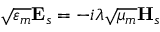<formula> <loc_0><loc_0><loc_500><loc_500>\sqrt { \varepsilon _ { m } } E _ { s } = - i \lambda \sqrt { \mu _ { m } } H _ { s }</formula> 